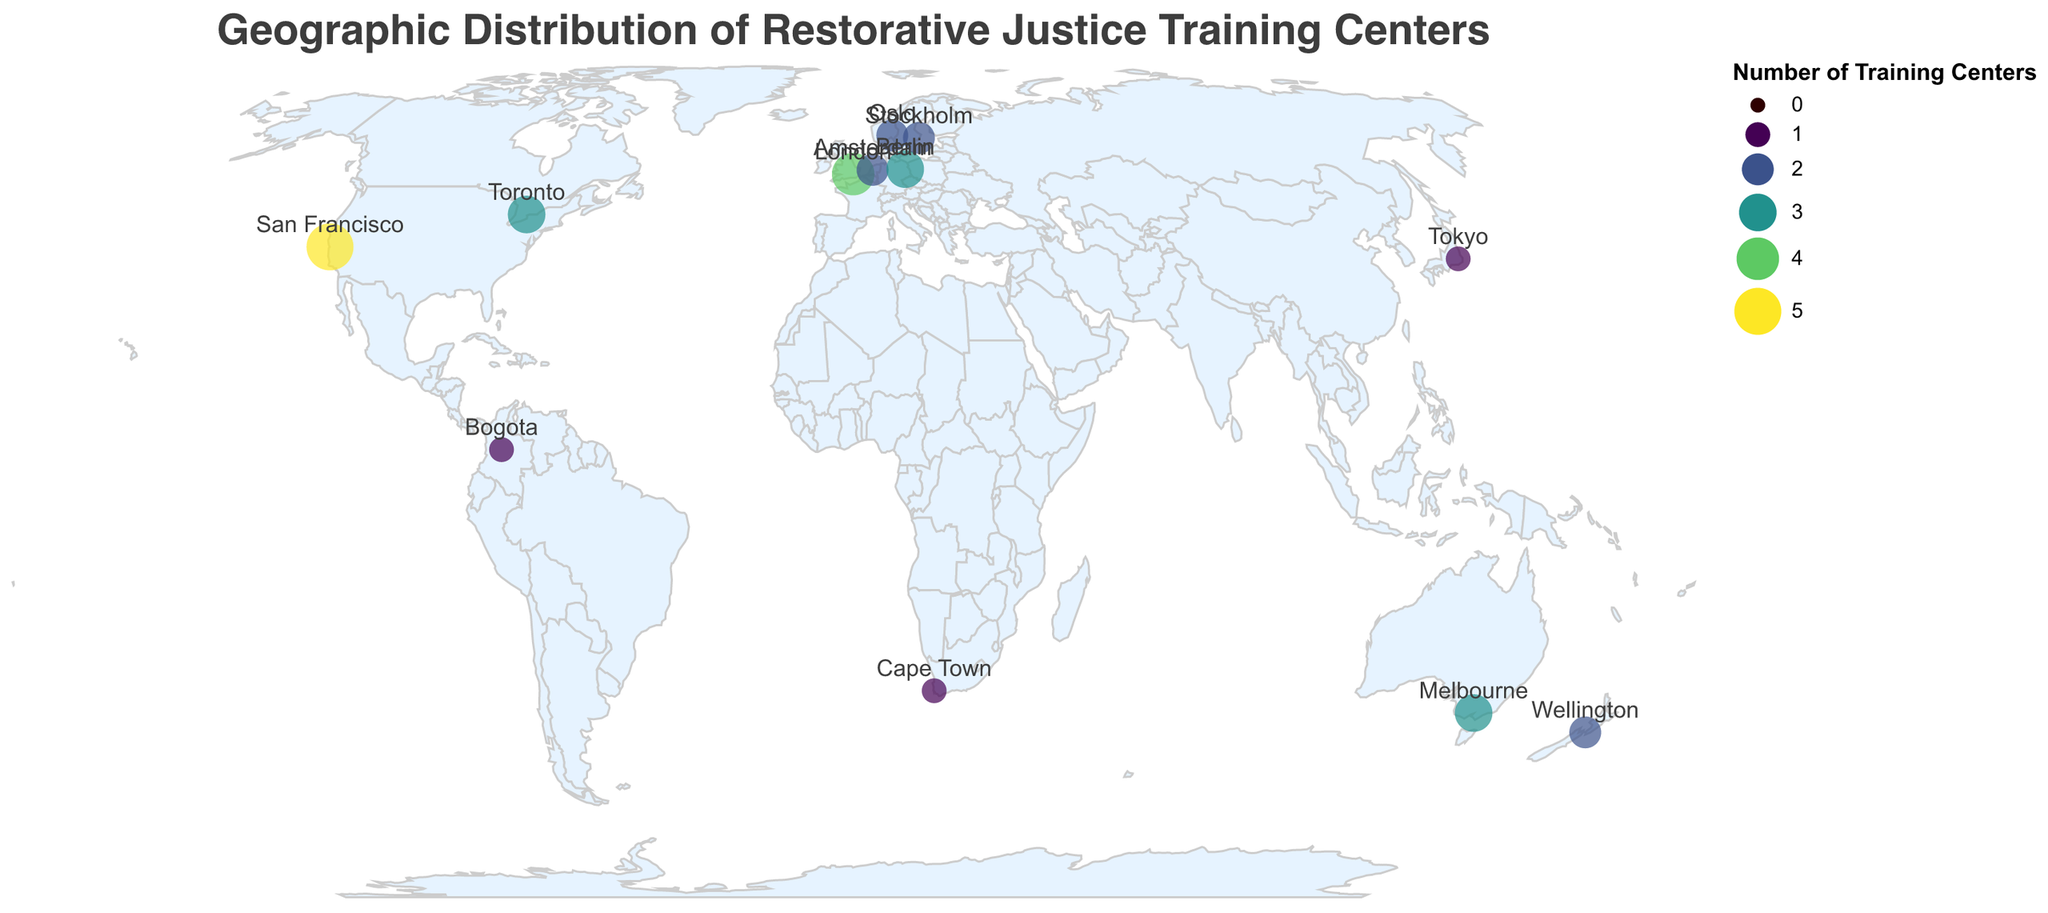What is the city with the highest number of restorative justice training centers? The city with the largest circle (indicative of training center count) is San Francisco, USA.
Answer: San Francisco How many cities have exactly 2 training centers for restorative justice? The cities with 2 training centers are Amsterdam, Wellington, Oslo, and Stockholm. Count these cities to get the answer.
Answer: 4 Which continents have cities with at least 3 training centers? Identify the cities with at least 3 training centers (Toronto, London, Melbourne, San Francisco, Berlin) and note their continents: North America, Europe, and Australia.
Answer: North America, Europe, Australia Are there more training centers in Europe or Asia based on the figure? In Europe, the cities are London (4), Amsterdam (2), Oslo (2), and Berlin (3), totaling 11 centers. In Asia, only Tokyo has 1 training center. By comparing the totals, Europe has more.
Answer: Europe Which city in the Southern Hemisphere has the most training centers? The Southern Hemisphere cities listed are Wellington (2), Cape Town (1), and Melbourne (3). Melbourne has the highest number with 3 training centers.
Answer: Melbourne What is the total number of training centers in the figure? Add the number of training centers from all cities: 3 (Toronto) + 4 (London) + 2 (Amsterdam) + 2 (Wellington) + 1 (Cape Town) + 2 (Oslo) + 3 (Melbourne) + 5 (San Francisco) + 1 (Tokyo) + 3 (Berlin) + 1 (Bogota) + 2 (Stockholm) = 29.
Answer: 29 Which city has the closest number of training centers to Cape Town? Cape Town has 1 training center. Other cities with 1 training center are Tokyo and Bogota, making them closest in number.
Answer: Tokyo, Bogota How many countries have exactly 1 city represented in the plot? The countries with only one city on the plot are Canada, UK, Netherlands, New Zealand, South Africa, Norway, Australia, USA, Japan, Germany, Colombia, and Sweden. There are 12 countries in total.
Answer: 12 How does the number of training centers in Stockholm compare to those in Wellington? Stockholm has 2 training centers, and Wellington also has 2 training centers. They have an equal number of training centers.
Answer: Equal 